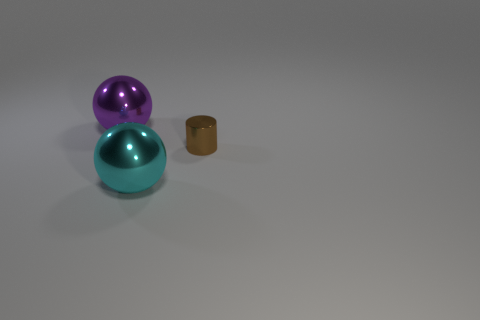What is the size of the sphere that is left of the ball in front of the large object on the left side of the large cyan shiny thing?
Your answer should be compact. Large. There is a sphere that is on the right side of the big thing that is behind the small object; what size is it?
Keep it short and to the point. Large. How many other things are there of the same size as the purple ball?
Your answer should be very brief. 1. There is a cyan metallic object; what number of metallic things are on the right side of it?
Your response must be concise. 1. How big is the purple metal object?
Provide a succinct answer. Large. Do the large object in front of the brown metallic cylinder and the large sphere that is behind the shiny cylinder have the same material?
Your response must be concise. Yes. Are there any large balls that have the same color as the tiny cylinder?
Provide a short and direct response. No. There is a thing that is the same size as the purple sphere; what is its color?
Offer a terse response. Cyan. Is the color of the large ball in front of the purple object the same as the small metal cylinder?
Offer a very short reply. No. Are there any other cyan spheres made of the same material as the large cyan sphere?
Your answer should be compact. No. 